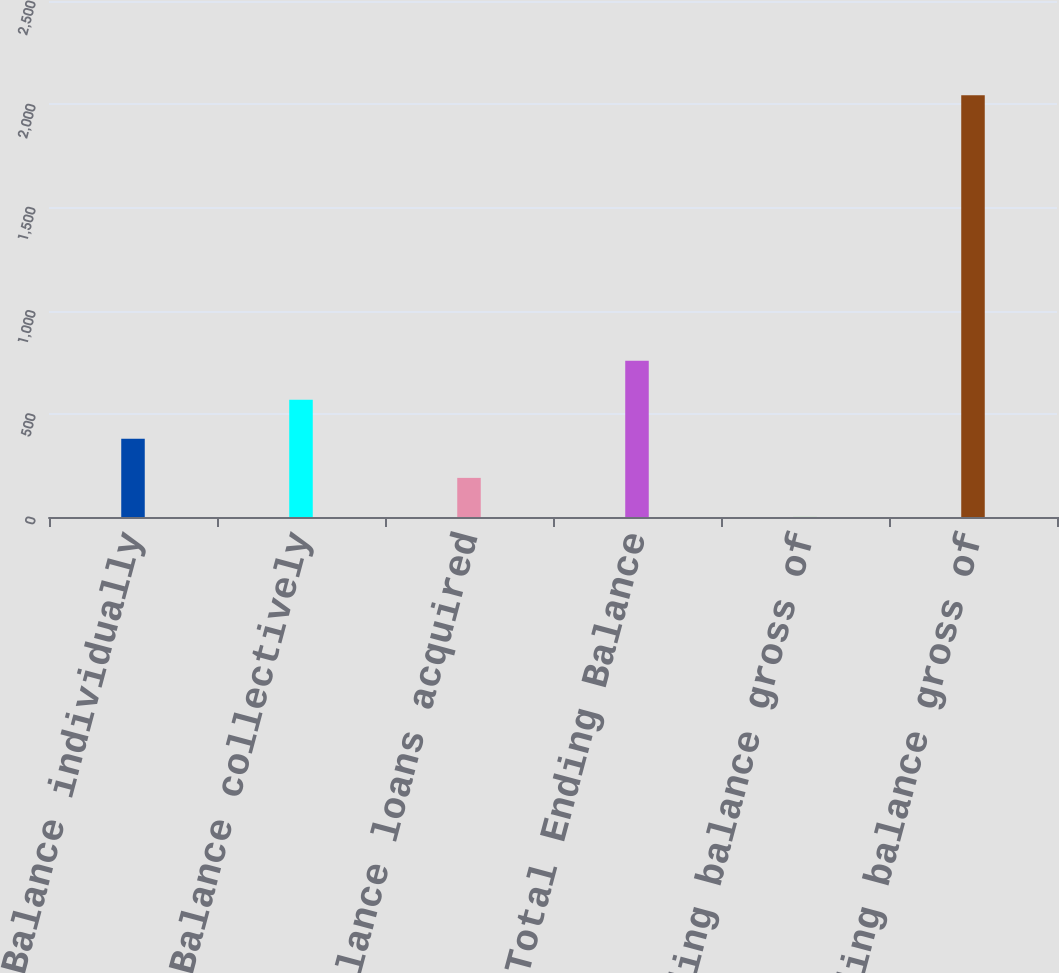Convert chart. <chart><loc_0><loc_0><loc_500><loc_500><bar_chart><fcel>Ending Balance individually<fcel>Ending Balance collectively<fcel>Ending Balance loans acquired<fcel>Total Ending Balance<fcel>Ending balance gross of<fcel>Total Ending balance gross of<nl><fcel>378.83<fcel>568.1<fcel>189.56<fcel>757.37<fcel>0.29<fcel>2043.27<nl></chart> 